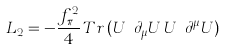<formula> <loc_0><loc_0><loc_500><loc_500>L _ { 2 } = - \frac { f _ { \pi } ^ { 2 } } { 4 } \, T r \, ( U ^ { \dagger } \partial _ { \mu } U \, U ^ { \dagger } \partial ^ { \mu } U )</formula> 